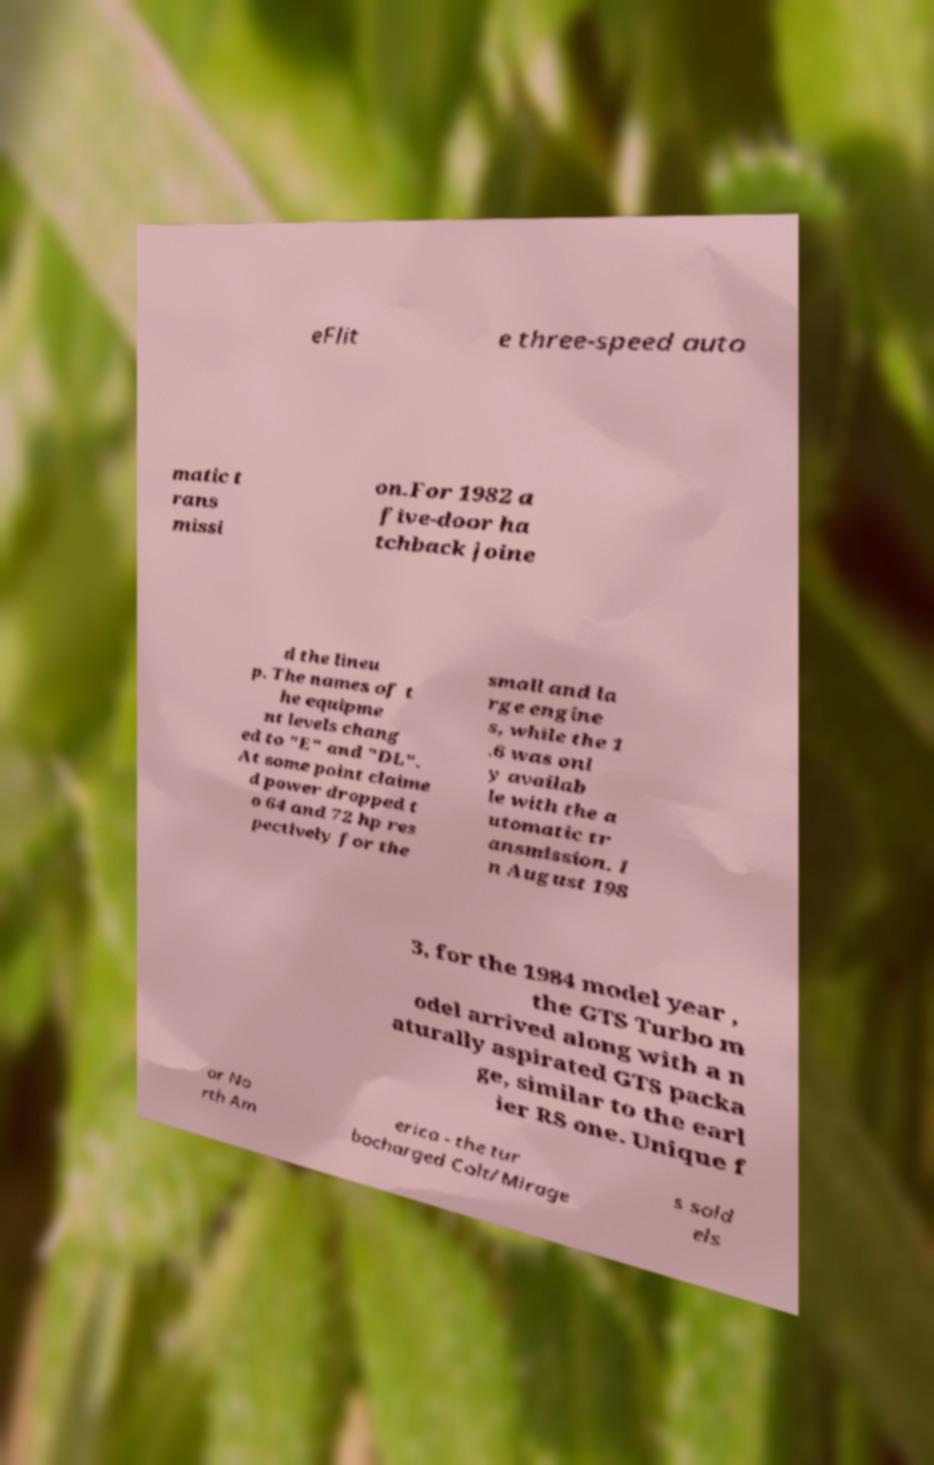Can you accurately transcribe the text from the provided image for me? eFlit e three-speed auto matic t rans missi on.For 1982 a five-door ha tchback joine d the lineu p. The names of t he equipme nt levels chang ed to "E" and "DL". At some point claime d power dropped t o 64 and 72 hp res pectively for the small and la rge engine s, while the 1 .6 was onl y availab le with the a utomatic tr ansmission. I n August 198 3, for the 1984 model year , the GTS Turbo m odel arrived along with a n aturally aspirated GTS packa ge, similar to the earl ier RS one. Unique f or No rth Am erica - the tur bocharged Colt/Mirage s sold els 